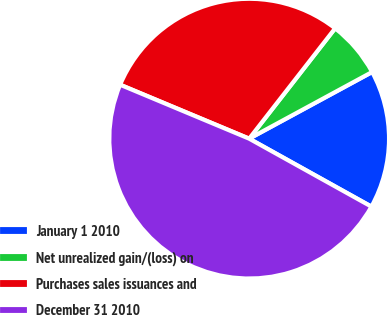Convert chart. <chart><loc_0><loc_0><loc_500><loc_500><pie_chart><fcel>January 1 2010<fcel>Net unrealized gain/(loss) on<fcel>Purchases sales issuances and<fcel>December 31 2010<nl><fcel>15.98%<fcel>6.56%<fcel>29.23%<fcel>48.22%<nl></chart> 